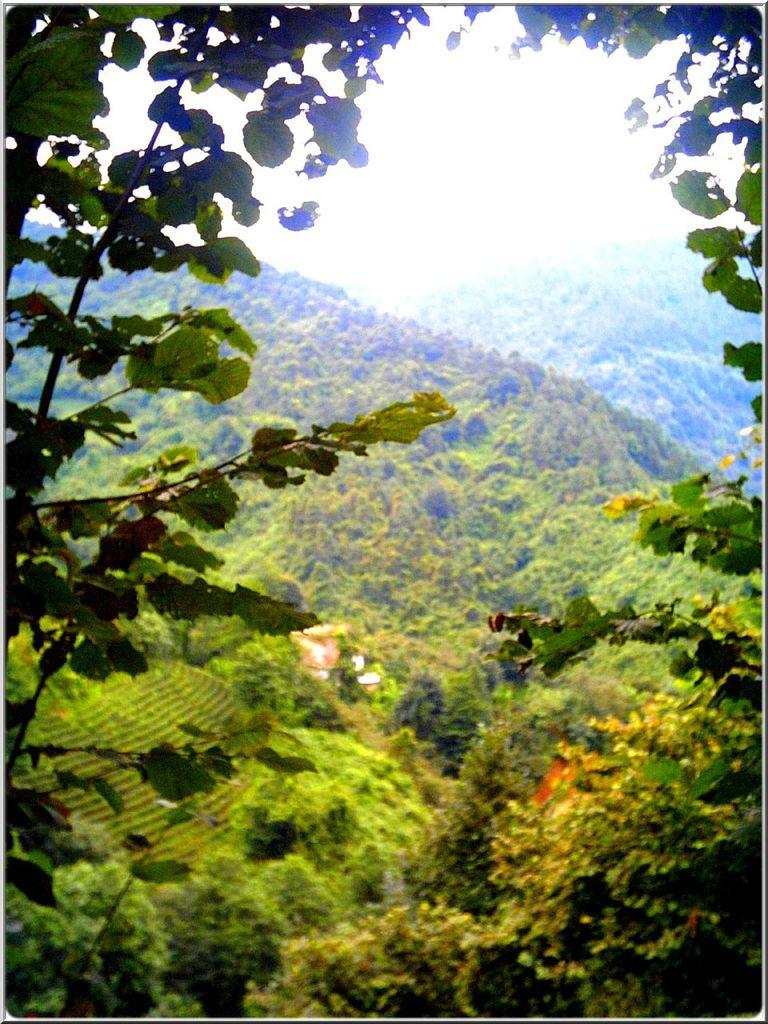What is located in the center of the image? There are trees and hills in the center of the image. What can be seen in the background of the image? The sky is visible in the image. What type of music can be heard coming from the trees in the image? There is no music present in the image, as it features trees and hills with no audible sounds. 